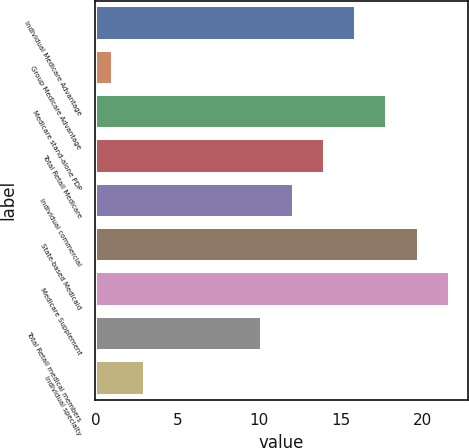Convert chart to OTSL. <chart><loc_0><loc_0><loc_500><loc_500><bar_chart><fcel>Individual Medicare Advantage<fcel>Group Medicare Advantage<fcel>Medicare stand-alone PDP<fcel>Total Retail Medicare<fcel>Individual commercial<fcel>State-based Medicaid<fcel>Medicare Supplement<fcel>Total Retail medical members<fcel>Individual specialty<nl><fcel>15.93<fcel>1.1<fcel>17.84<fcel>14.02<fcel>12.11<fcel>19.75<fcel>21.66<fcel>10.2<fcel>3.01<nl></chart> 